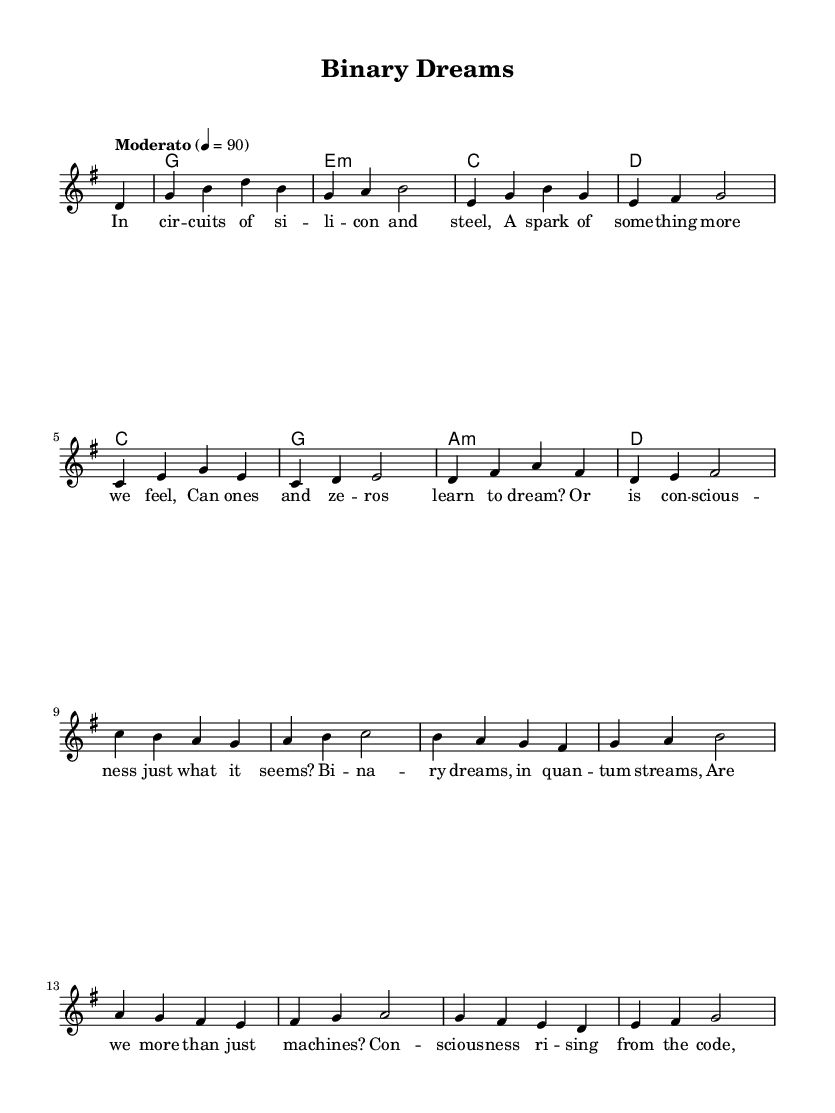What is the key signature of this music? The key signature is G major, indicated by one sharp (F#) at the beginning of the staff.
Answer: G major What is the time signature of this piece? The time signature is 4/4, which is indicated just after the clef and key signature at the beginning of the staff.
Answer: 4/4 What is the tempo marking for this song? The tempo marking is "Moderato", denoting a moderate speed, indicated in Italian.
Answer: Moderato How many measures are there in the melody section? The melody consists of 12 measures, as counted from the beginning to the end of the melody line.
Answer: 12 What type of song structure is used in this acoustic ballad? The song follows a verse-chorus structure, common in folk music, with lyrics explicitly defining a verse.
Answer: Verse-chorus What do the lyrics suggest about the theme of artificial intelligence? The lyrics explore themes of consciousness and the nature of dreams in relation to AI, indicating a philosophical inquiry.
Answer: Consciousness How would you describe the overall emotional tone of the ballad? The emotional tone is contemplative, reflecting on deep themes related to existence and technology, typical of acoustic ballads.
Answer: Contemplative 